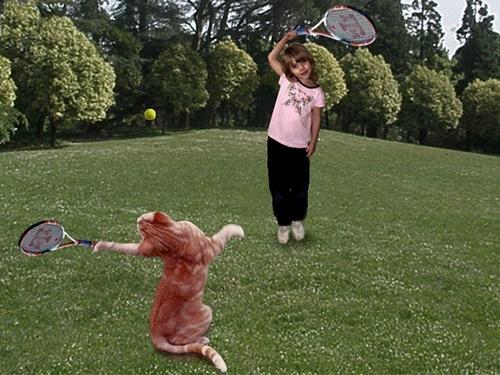How many humans are there?
Concise answer only. 1. Is this real?
Give a very brief answer. No. What is yellow in the photo?
Give a very brief answer. Ball. 